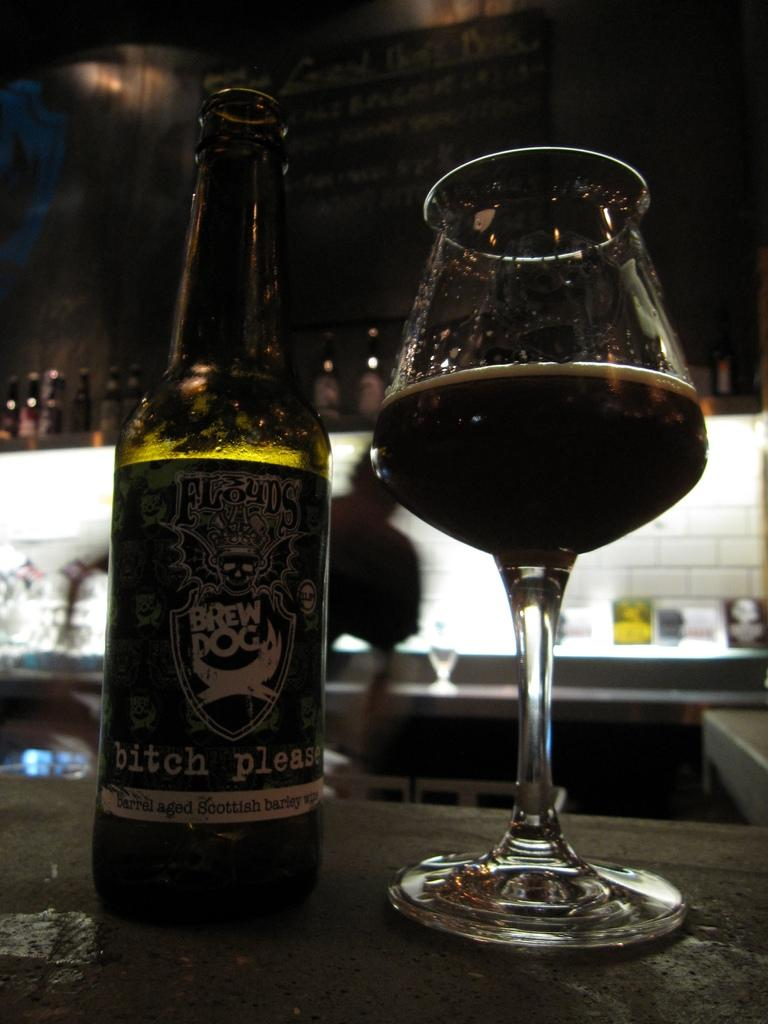What piece of furniture is present in the image? There is a table in the image. What is placed on the table? There is a bottle and a glass with liquid on the table. Can you describe the person in the background of the image? There is a person in the background of the image, but no specific details are provided. What else can be seen near the person? There are many bottles near the person. What type of doll is being used to play volleyball in the image? There is no doll or volleyball present in the image. 